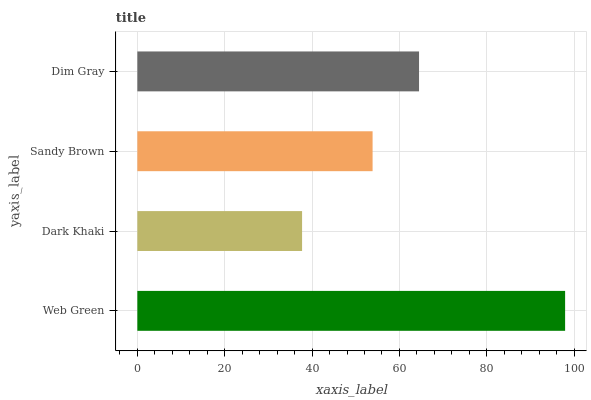Is Dark Khaki the minimum?
Answer yes or no. Yes. Is Web Green the maximum?
Answer yes or no. Yes. Is Sandy Brown the minimum?
Answer yes or no. No. Is Sandy Brown the maximum?
Answer yes or no. No. Is Sandy Brown greater than Dark Khaki?
Answer yes or no. Yes. Is Dark Khaki less than Sandy Brown?
Answer yes or no. Yes. Is Dark Khaki greater than Sandy Brown?
Answer yes or no. No. Is Sandy Brown less than Dark Khaki?
Answer yes or no. No. Is Dim Gray the high median?
Answer yes or no. Yes. Is Sandy Brown the low median?
Answer yes or no. Yes. Is Dark Khaki the high median?
Answer yes or no. No. Is Dark Khaki the low median?
Answer yes or no. No. 